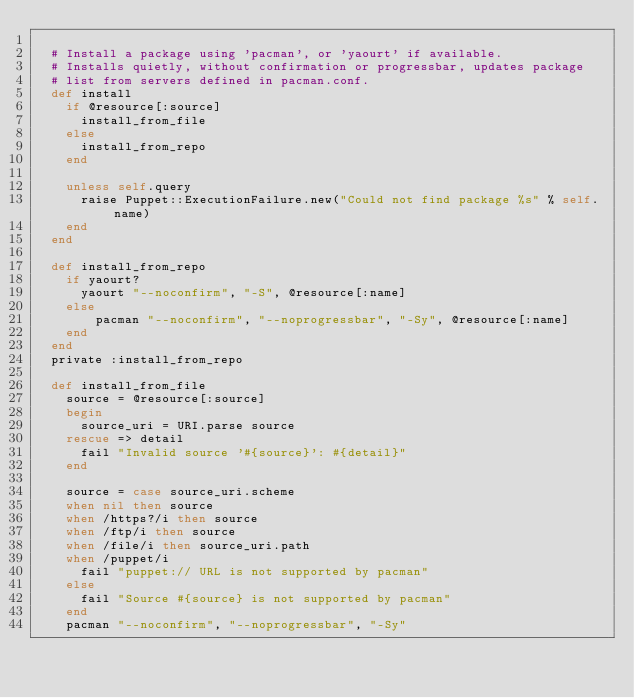<code> <loc_0><loc_0><loc_500><loc_500><_Ruby_>
  # Install a package using 'pacman', or 'yaourt' if available.
  # Installs quietly, without confirmation or progressbar, updates package
  # list from servers defined in pacman.conf.
  def install
    if @resource[:source]
      install_from_file
    else
      install_from_repo
    end

    unless self.query
      raise Puppet::ExecutionFailure.new("Could not find package %s" % self.name)
    end
  end

  def install_from_repo
    if yaourt?
      yaourt "--noconfirm", "-S", @resource[:name]
    else
        pacman "--noconfirm", "--noprogressbar", "-Sy", @resource[:name]
    end
  end
  private :install_from_repo

  def install_from_file
    source = @resource[:source]
    begin
      source_uri = URI.parse source
    rescue => detail
      fail "Invalid source '#{source}': #{detail}"
    end

    source = case source_uri.scheme
    when nil then source
    when /https?/i then source
    when /ftp/i then source
    when /file/i then source_uri.path
    when /puppet/i
      fail "puppet:// URL is not supported by pacman"
    else
      fail "Source #{source} is not supported by pacman"
    end
    pacman "--noconfirm", "--noprogressbar", "-Sy"</code> 